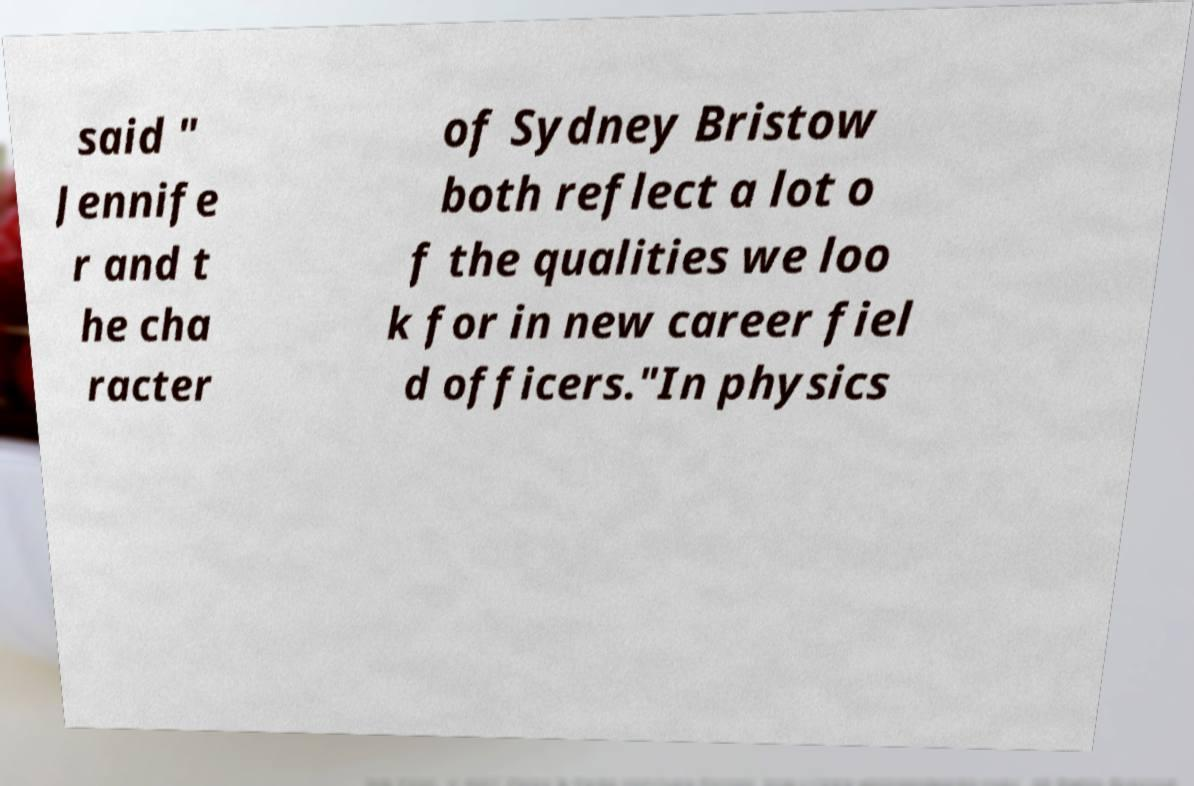Can you read and provide the text displayed in the image?This photo seems to have some interesting text. Can you extract and type it out for me? said " Jennife r and t he cha racter of Sydney Bristow both reflect a lot o f the qualities we loo k for in new career fiel d officers."In physics 